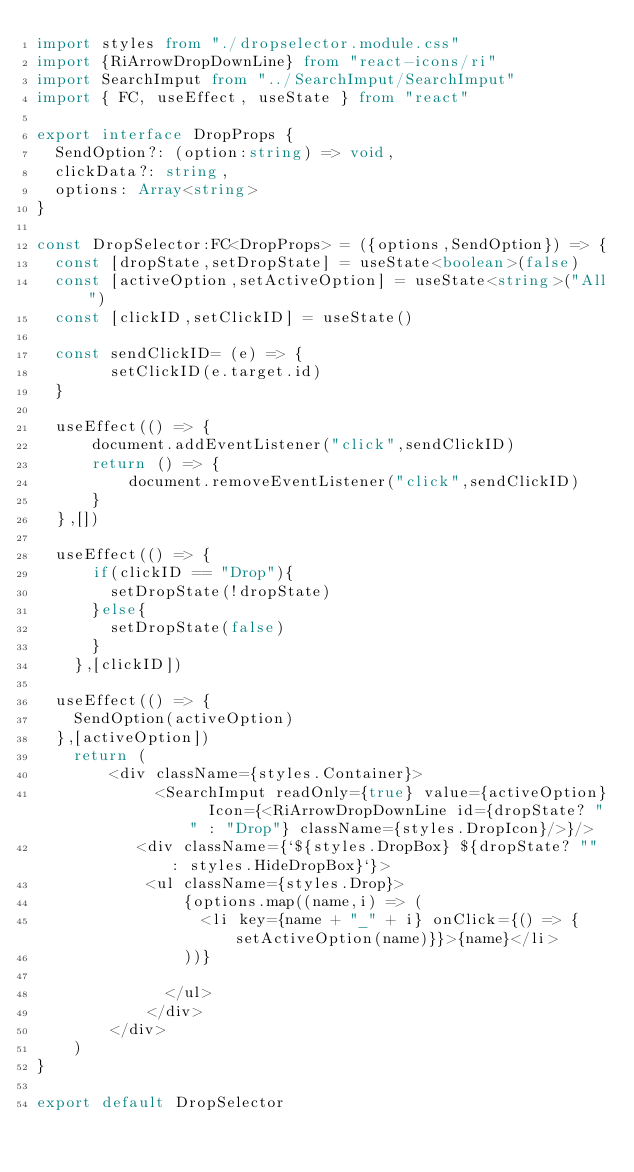<code> <loc_0><loc_0><loc_500><loc_500><_TypeScript_>import styles from "./dropselector.module.css"
import {RiArrowDropDownLine} from "react-icons/ri"
import SearchImput from "../SearchImput/SearchImput"
import { FC, useEffect, useState } from "react"

export interface DropProps {
  SendOption?: (option:string) => void,
  clickData?: string,
  options: Array<string>
}

const DropSelector:FC<DropProps> = ({options,SendOption}) => {
  const [dropState,setDropState] = useState<boolean>(false)
  const [activeOption,setActiveOption] = useState<string>("All")  
  const [clickID,setClickID] = useState()
  
  const sendClickID= (e) => {
        setClickID(e.target.id)
  }
    
  useEffect(() => {
      document.addEventListener("click",sendClickID)
      return () => {
          document.removeEventListener("click",sendClickID)
      }
  },[])
 
  useEffect(() => {
      if(clickID == "Drop"){
        setDropState(!dropState)
      }else{
        setDropState(false)
      }
    },[clickID])

  useEffect(() => {
    SendOption(activeOption)
  },[activeOption])
    return (
        <div className={styles.Container}>
             <SearchImput readOnly={true} value={activeOption}  Icon={<RiArrowDropDownLine id={dropState? "" : "Drop"} className={styles.DropIcon}/>}/>
           <div className={`${styles.DropBox} ${dropState? "" : styles.HideDropBox}`}> 
            <ul className={styles.Drop}>
                {options.map((name,i) => (
                  <li key={name + "_" + i} onClick={() => {setActiveOption(name)}}>{name}</li>
                ))}

              </ul>
            </div>
        </div>
    )
}

export default DropSelector
</code> 